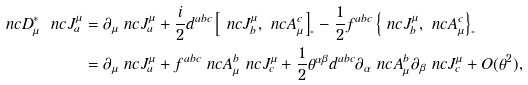<formula> <loc_0><loc_0><loc_500><loc_500>\ n c { D } _ { \mu } ^ { * } \ n c { J } ^ { \mu } _ { a } & = \partial _ { \mu } \ n c { J } ^ { \mu } _ { a } + \frac { i } { 2 } d ^ { a b c } \left [ \ n c { J } ^ { \mu } _ { b } , \ n c { A } _ { \mu } ^ { c } \right ] _ { ^ { * } } - \frac { 1 } { 2 } f ^ { a b c } \left \{ \ n c { J } ^ { \mu } _ { b } , \ n c { A } _ { \mu } ^ { c } \right \} _ { ^ { * } } \\ & = \partial _ { \mu } \ n c { J } ^ { \mu } _ { a } + f ^ { a b c } \ n c { A } _ { \mu } ^ { b } \ n c { J } ^ { \mu } _ { c } + \frac { 1 } { 2 } \theta ^ { \alpha \beta } d ^ { a b c } \partial _ { \alpha } \ n c { A } _ { \mu } ^ { b } \partial _ { \beta } \ n c { J } ^ { \mu } _ { c } + O ( \theta ^ { 2 } ) ,</formula> 